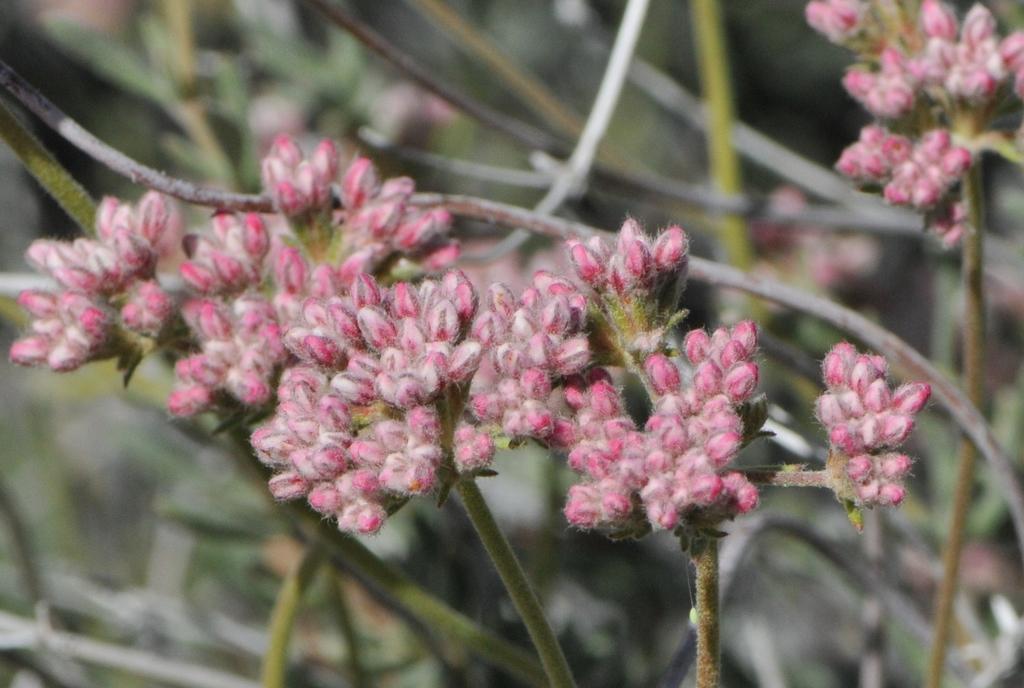Please provide a concise description of this image. As we can see in the image there are plants and flowers. 